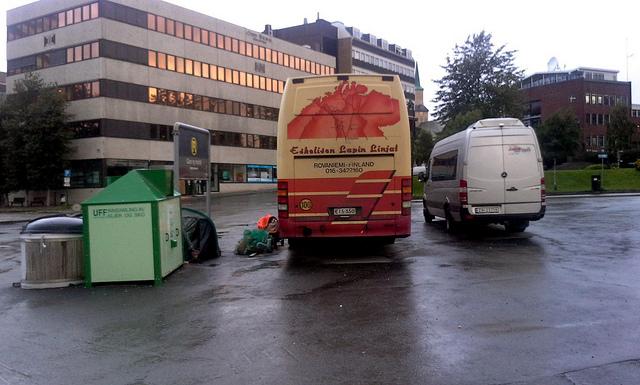What does the writing on the back of the bus say?
Quick response, please. Can't read it. What color is the van?
Be succinct. White. What is on the ground to the left of the bus?
Give a very brief answer. Luggage. 